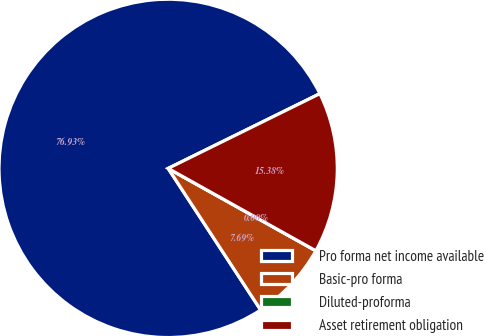<chart> <loc_0><loc_0><loc_500><loc_500><pie_chart><fcel>Pro forma net income available<fcel>Basic-pro forma<fcel>Diluted-proforma<fcel>Asset retirement obligation<nl><fcel>76.92%<fcel>7.69%<fcel>0.0%<fcel>15.38%<nl></chart> 